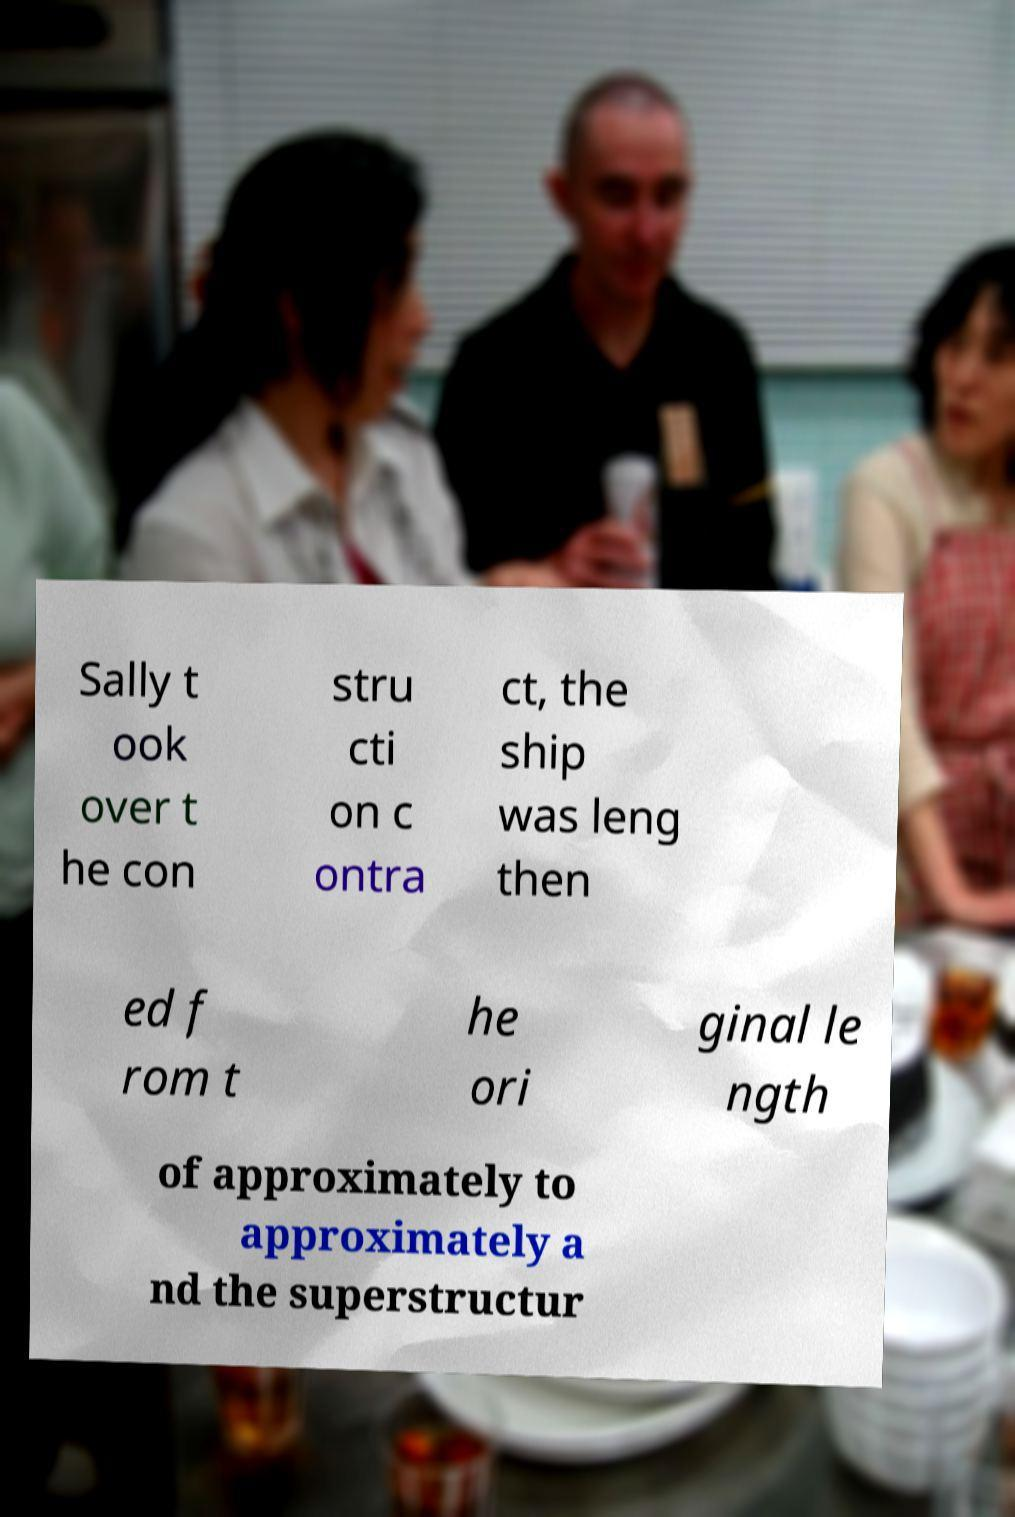What messages or text are displayed in this image? I need them in a readable, typed format. Sally t ook over t he con stru cti on c ontra ct, the ship was leng then ed f rom t he ori ginal le ngth of approximately to approximately a nd the superstructur 